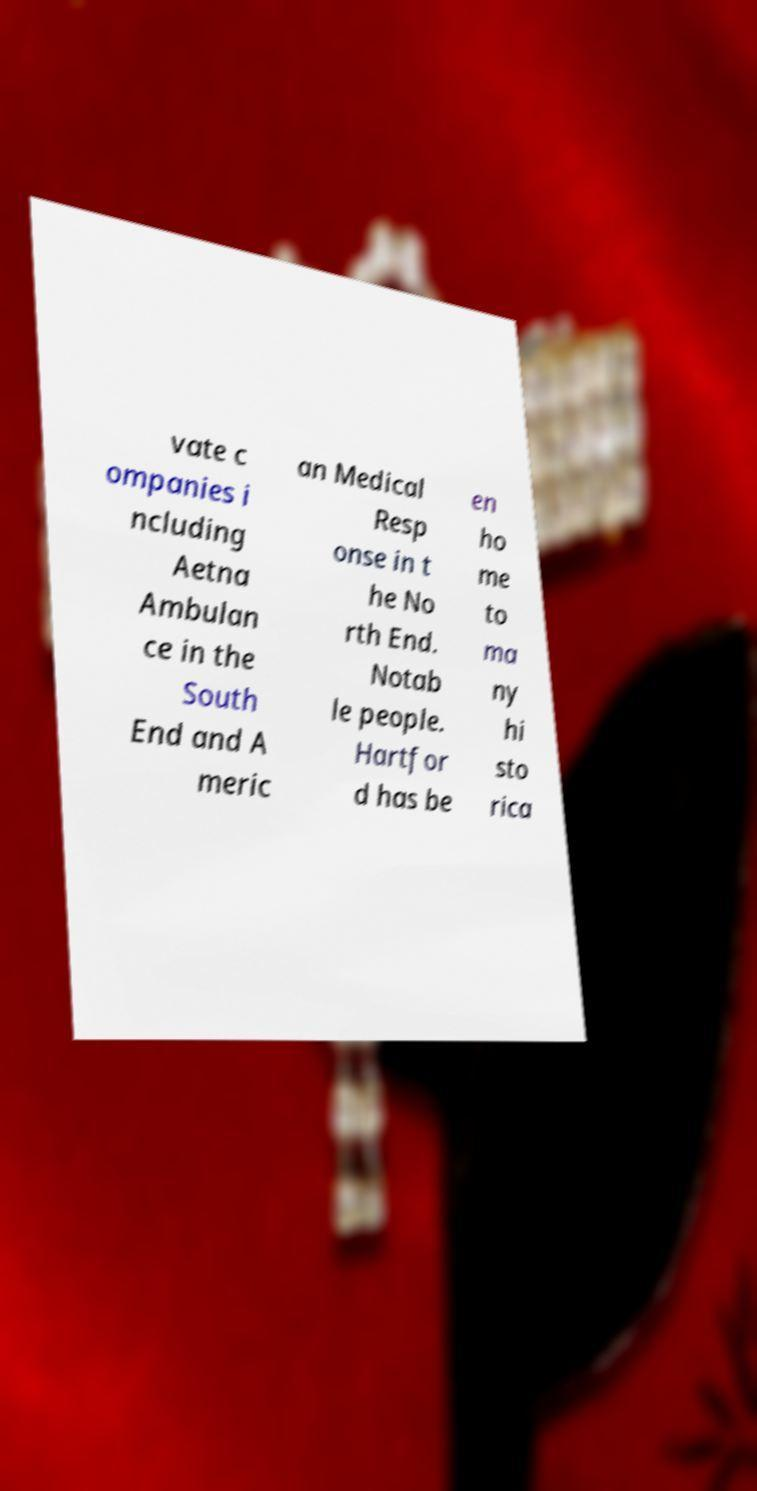There's text embedded in this image that I need extracted. Can you transcribe it verbatim? vate c ompanies i ncluding Aetna Ambulan ce in the South End and A meric an Medical Resp onse in t he No rth End. Notab le people. Hartfor d has be en ho me to ma ny hi sto rica 